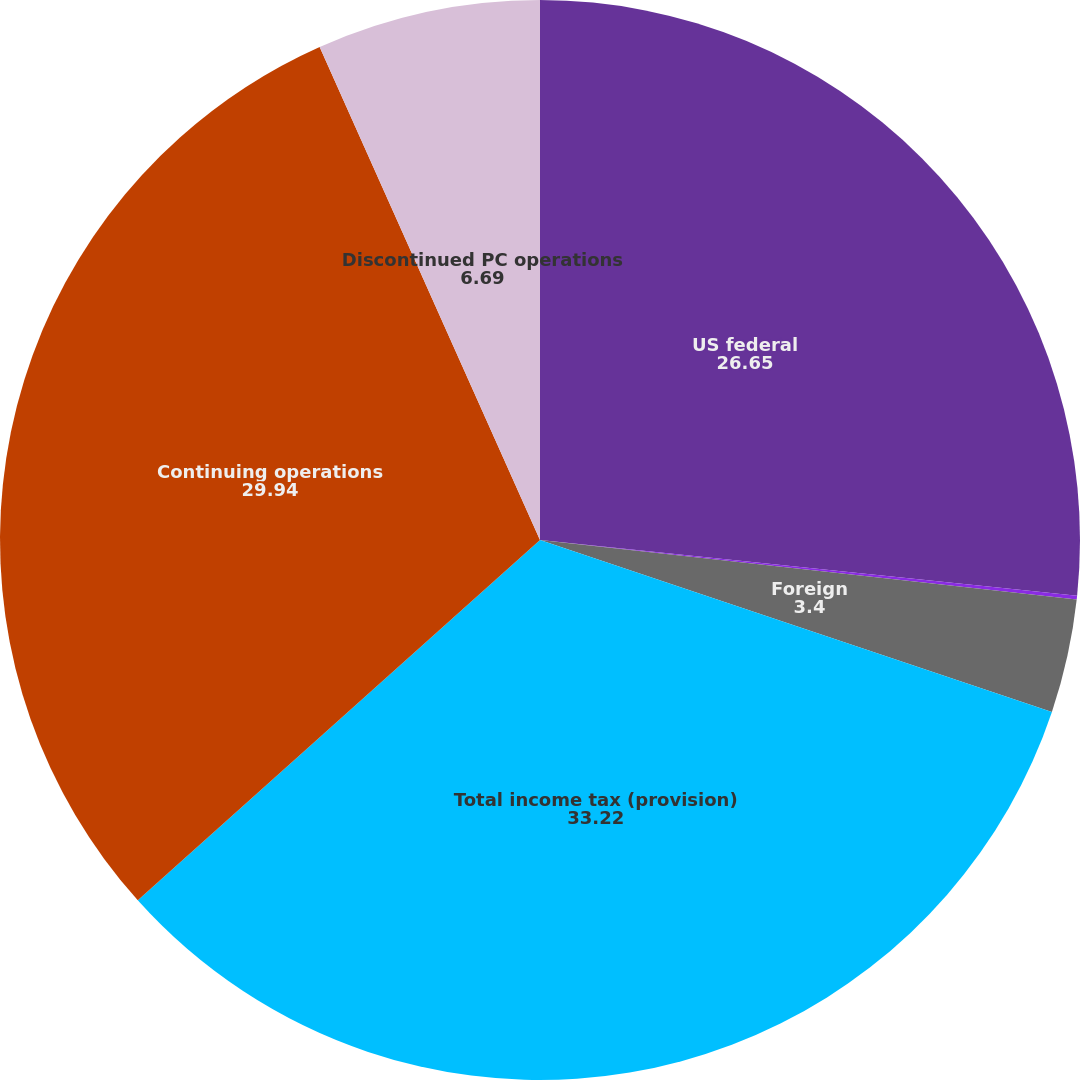Convert chart. <chart><loc_0><loc_0><loc_500><loc_500><pie_chart><fcel>US federal<fcel>State<fcel>Foreign<fcel>Total income tax (provision)<fcel>Continuing operations<fcel>Discontinued PC operations<nl><fcel>26.65%<fcel>0.11%<fcel>3.4%<fcel>33.22%<fcel>29.94%<fcel>6.69%<nl></chart> 